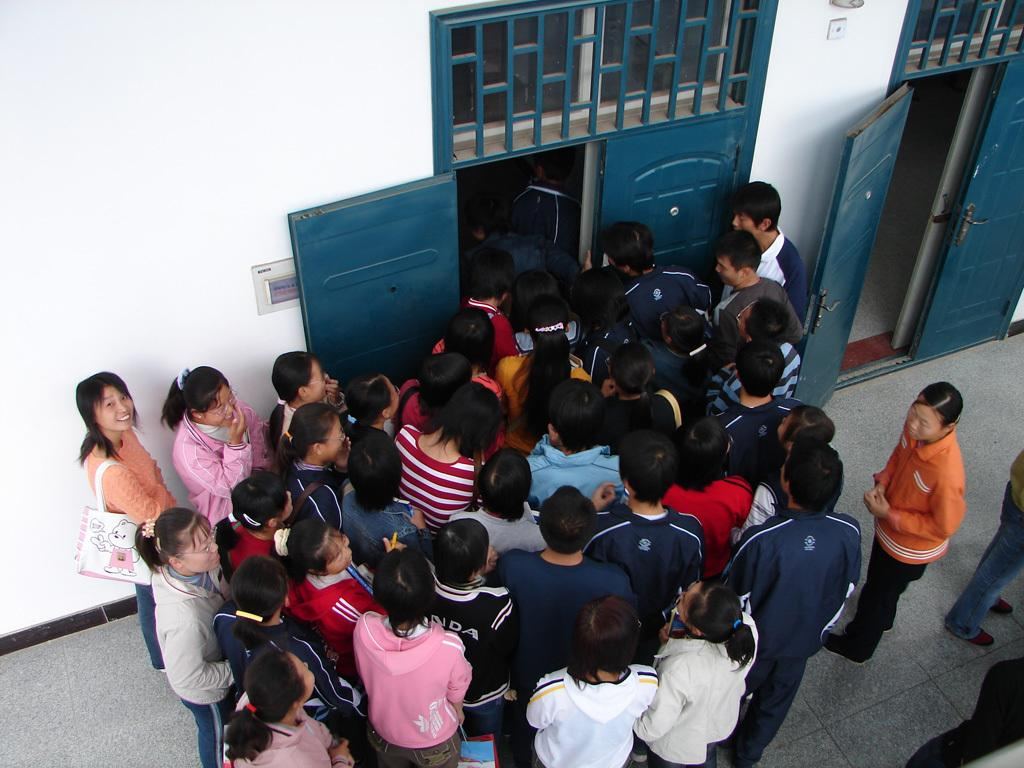What can be seen in the image? There are people standing in the image. What architectural features are present in the image? There is a door and a wall visible in the image. What is the surface that the people are standing on? There is a floor visible at the bottom of the image. Where is the door located in the image? The door is located to the right side of the image. What type of spoon is being used for reading in the image? There is no spoon or reading activity present in the image. 